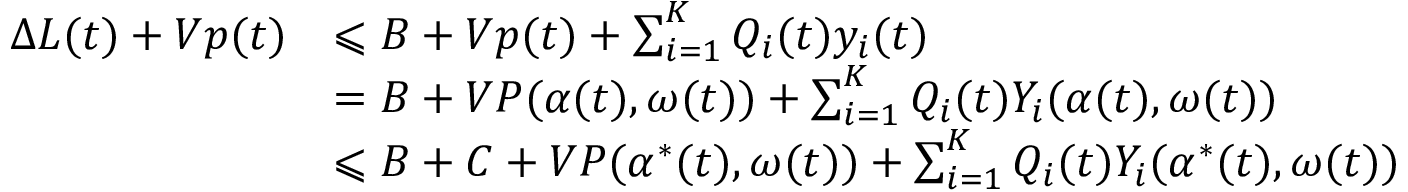<formula> <loc_0><loc_0><loc_500><loc_500>{ \begin{array} { r l } { \Delta L ( t ) + V p ( t ) } & { \leqslant B + V p ( t ) + \sum _ { i = 1 } ^ { K } Q _ { i } ( t ) y _ { i } ( t ) } \\ & { = B + V P ( \alpha ( t ) , \omega ( t ) ) + \sum _ { i = 1 } ^ { K } Q _ { i } ( t ) Y _ { i } ( \alpha ( t ) , \omega ( t ) ) } \\ & { \leqslant B + C + V P ( \alpha ^ { * } ( t ) , \omega ( t ) ) + \sum _ { i = 1 } ^ { K } Q _ { i } ( t ) Y _ { i } ( \alpha ^ { * } ( t ) , \omega ( t ) ) } \end{array} }</formula> 